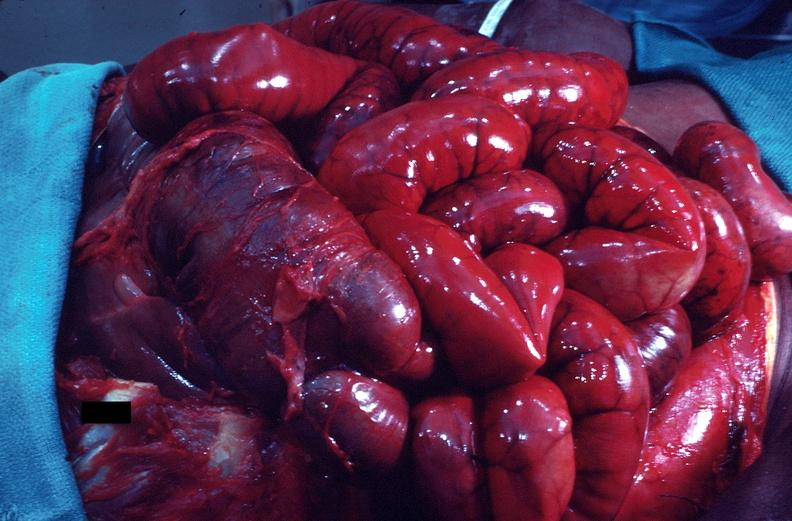does an opened peritoneal cavity cause by fibrous band strangulation show intestine in situ, congestion and early ischemic necrosis?
Answer the question using a single word or phrase. No 